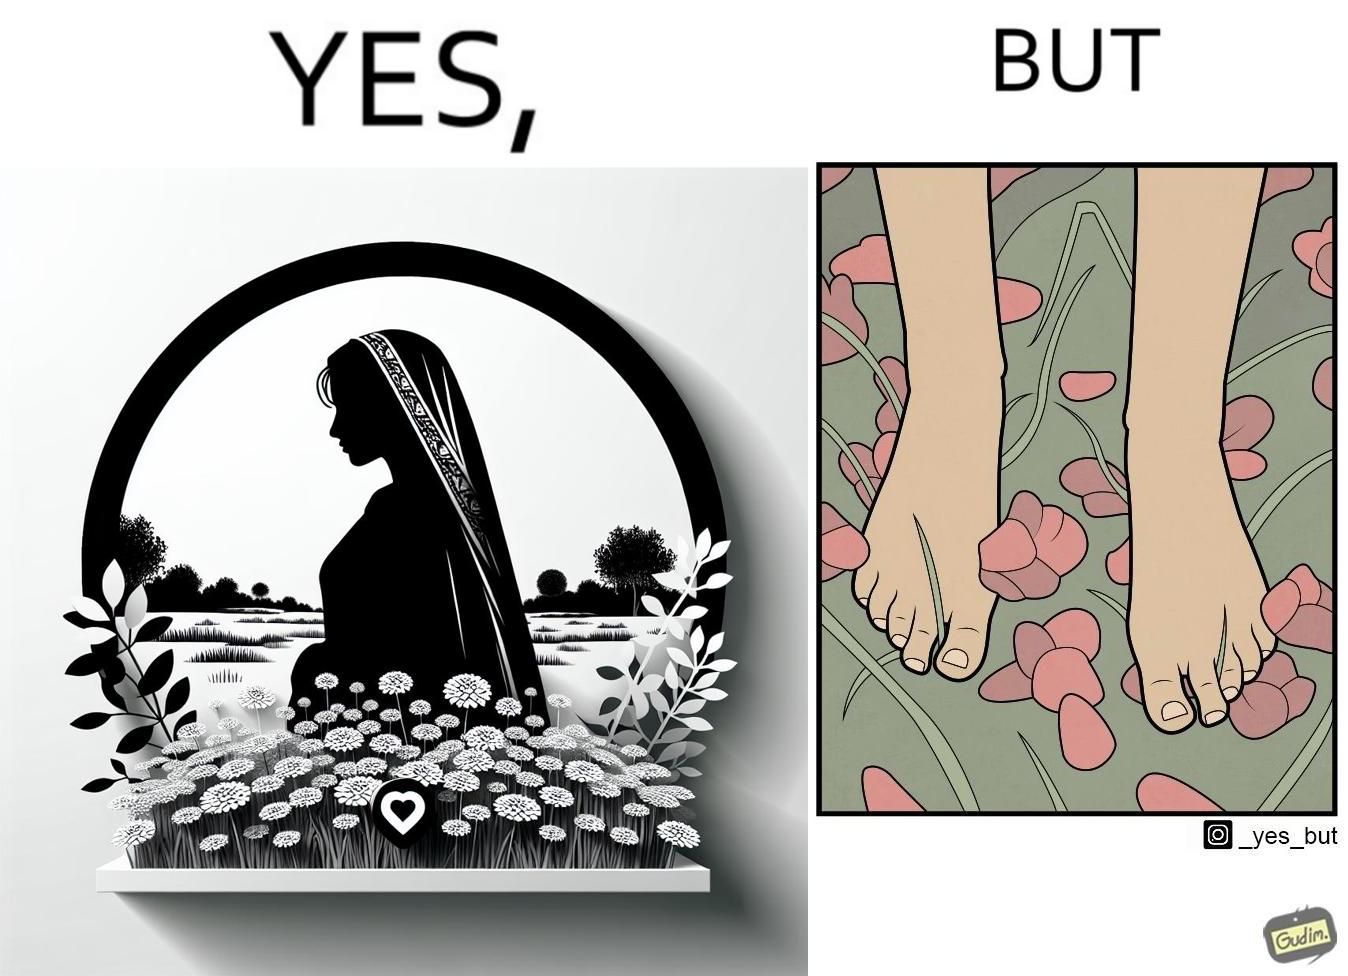Describe what you see in this image. The image is ironical, as the social ,edia post shows the appreciation of nature, while an image of the feet on the ground stepping on the flower petals shows an unintentional disrespect of nature. 